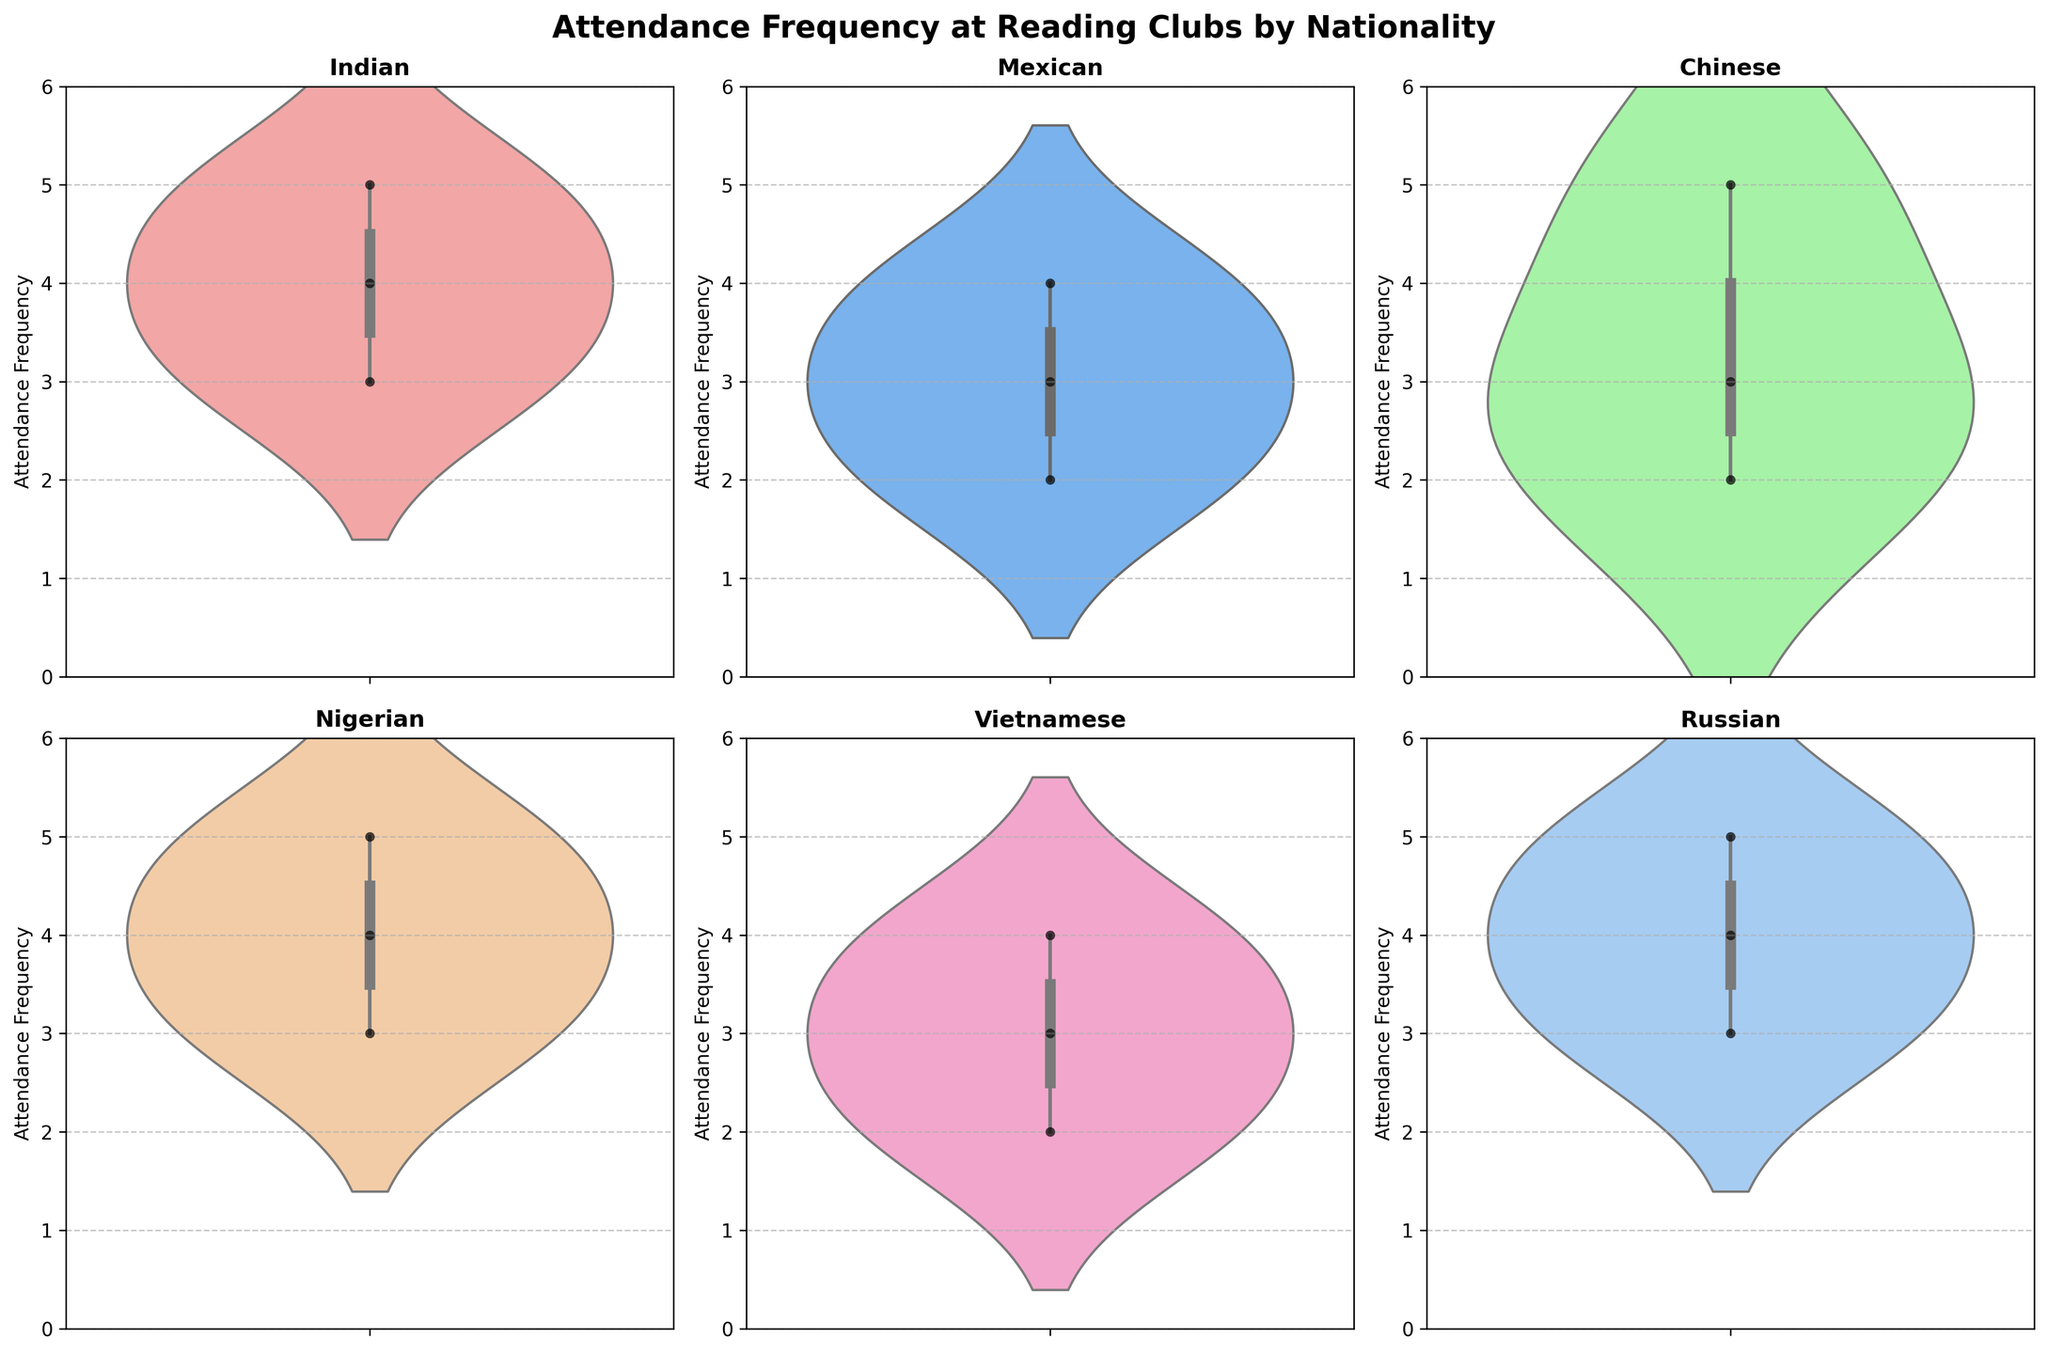What is the title of the figure? The title of the figure is usually displayed at the top and provides a summary of what the chart is about. In this case, it mentions both the attendance frequency and the nationalities involved.
Answer: Attendance Frequency at Reading Clubs by Nationality Which nationality has the highest attendance frequency? To find the highest attendance frequency, we need to look at the violin plot for each nationality and identify the plot with the highest point. The plot for Indian and Nigerian nationalities reach the frequency of 5, which is the highest shown.
Answer: Indian and Nigerian How many nationalities are compared in the figure? The number of nationalities can be determined by counting the distinct subplots. Each subplot represents a different nationality.
Answer: 6 What is the general shape of the attendance distribution for the Mexican nationality? By examining the violin plot for the Mexican nationality, we can observe its distribution shape which shows the frequency spread and density along the y-axis.
Answer: Symmetrically distributed around frequencies 2, 3, and 4 Which nationality has the most variability in attendance frequency? The nationality with the widest range of attendance frequencies or the most spread out under the violin plot indicates higher variability. Looking at all the plots, Indian and Nigerian nationalities have data points ranging from 3 to 5.
Answer: Indian and Nigerian What is the range of attendance frequencies for the Chinese nationality? The range can be found by identifying the minimum and maximum points within the Chinese nationality’s violin plot. The data points for Chinese are from 2 to 5.
Answer: 2 to 5 What is the common range of attendance frequency for all nationalities? By looking at the y-axis and finding the common range that each violin plot covers, we can determine the common range of attendance frequency across all nationalities.
Answer: 2 to 5 Is there any nationality with a unimodal distribution in attendance frequency? A unimodal distribution would show a single peak within the violin plot. We need to identify if any of the plots show a single concentrated area. Mexican nationality shows a single peak around 3, indicating unimodal behavior.
Answer: Yes, Mexican Which nationalities' median attendance frequency is exactly 4? The median attendance frequency is at the central horizontal line of the densest part of each violin plot. Indian and Nigerian plots place their median frequencies around a central value of 4.
Answer: Indian and Nigerian What is the primary difference in attendance frequency between the Russian and Vietnamese nationalities? By directly comparing the violin plots of Russian and Vietnamese nationalities, we can observe the main differences in how the data points are spread and their central tendencies. Both distributions show similar patterns, but subtle differences in density can be noted.
Answer: Similar distribution, both showing spread between 2 to 5 